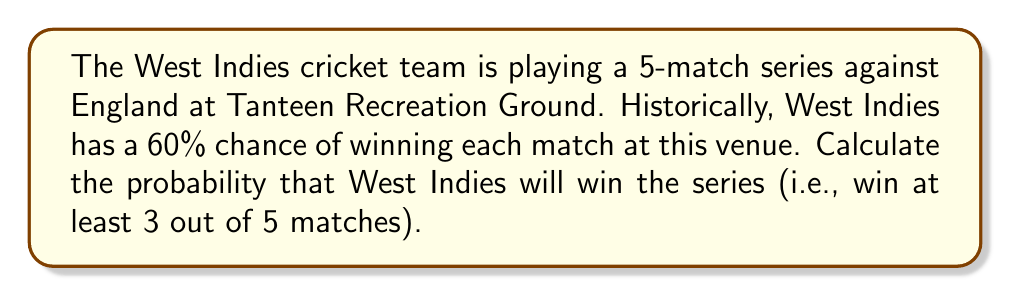Provide a solution to this math problem. Let's approach this step-by-step:

1) We need to find the probability of West Indies winning 3, 4, or 5 matches out of 5.

2) This follows a binomial probability distribution with:
   $n = 5$ (total number of matches)
   $p = 0.6$ (probability of winning each match)

3) The probability of exactly $k$ successes in $n$ trials is given by:

   $$P(X = k) = \binom{n}{k} p^k (1-p)^{n-k}$$

4) We need to calculate this for $k = 3$, $k = 4$, and $k = 5$:

   For $k = 3$:
   $$P(X = 3) = \binom{5}{3} (0.6)^3 (0.4)^2 = 10 \times 0.216 \times 0.16 = 0.3456$$

   For $k = 4$:
   $$P(X = 4) = \binom{5}{4} (0.6)^4 (0.4)^1 = 5 \times 0.1296 \times 0.4 = 0.2592$$

   For $k = 5$:
   $$P(X = 5) = \binom{5}{5} (0.6)^5 (0.4)^0 = 1 \times 0.07776 \times 1 = 0.07776$$

5) The total probability of winning the series is the sum of these probabilities:

   $$P(\text{winning series}) = P(X = 3) + P(X = 4) + P(X = 5)$$
   $$= 0.3456 + 0.2592 + 0.07776 = 0.68256$$

6) Therefore, the probability of West Indies winning the series is approximately 0.6826 or 68.26%.
Answer: 0.6826 